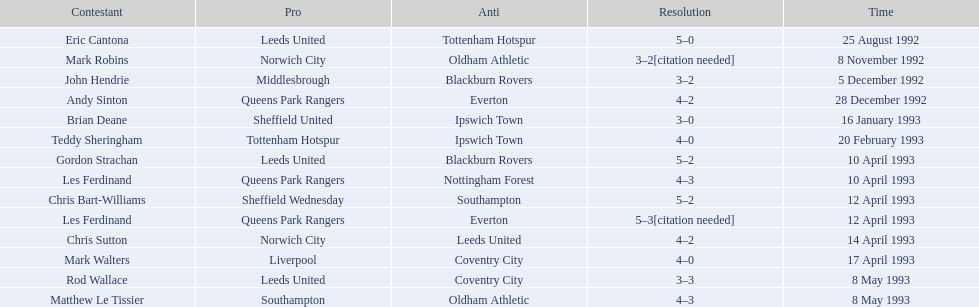What was the result of the match between queens park rangers and everton? 4-2. 